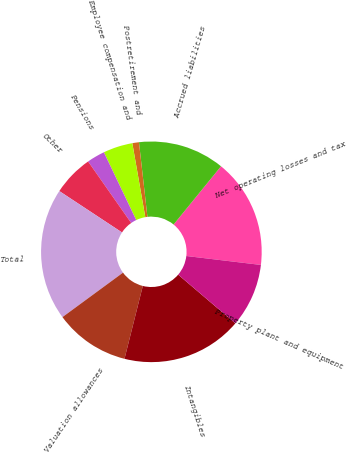Convert chart to OTSL. <chart><loc_0><loc_0><loc_500><loc_500><pie_chart><fcel>Net operating losses and tax<fcel>Accrued liabilities<fcel>Postretirement and<fcel>Employee compensation and<fcel>Pensions<fcel>Other<fcel>Total<fcel>Valuation allowances<fcel>Intangibles<fcel>Property plant and equipment<nl><fcel>16.02%<fcel>12.67%<fcel>0.97%<fcel>4.32%<fcel>2.64%<fcel>5.99%<fcel>19.36%<fcel>11.0%<fcel>17.69%<fcel>9.33%<nl></chart> 